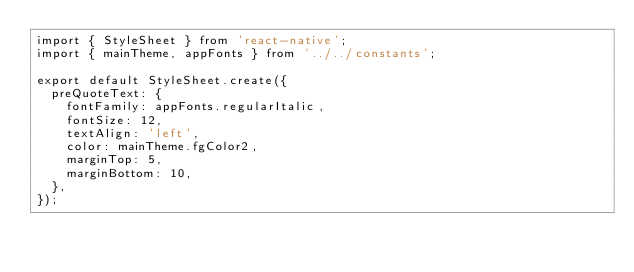Convert code to text. <code><loc_0><loc_0><loc_500><loc_500><_JavaScript_>import { StyleSheet } from 'react-native';
import { mainTheme, appFonts } from '../../constants';

export default StyleSheet.create({
  preQuoteText: {
    fontFamily: appFonts.regularItalic,
    fontSize: 12,
    textAlign: 'left',
    color: mainTheme.fgColor2,
    marginTop: 5,
    marginBottom: 10,
  },
});
</code> 